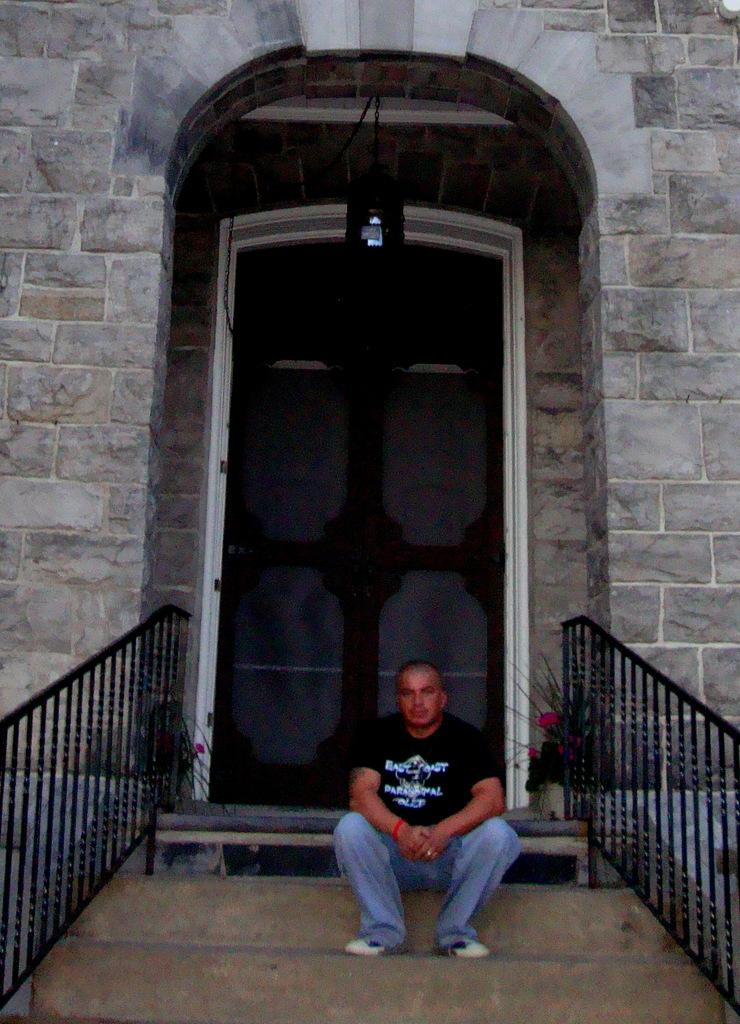What is the position of the man in the image? There is a man sitting at the bottom of the image. What can be seen on the sides of the image? There are railings on either side of the image. What is located at the top of the image? There is an entrance at the top of the image. What is the man's income in the image? There is no information about the man's income in the image. How many bikes are parked near the entrance in the image? There are no bikes present in the image. 